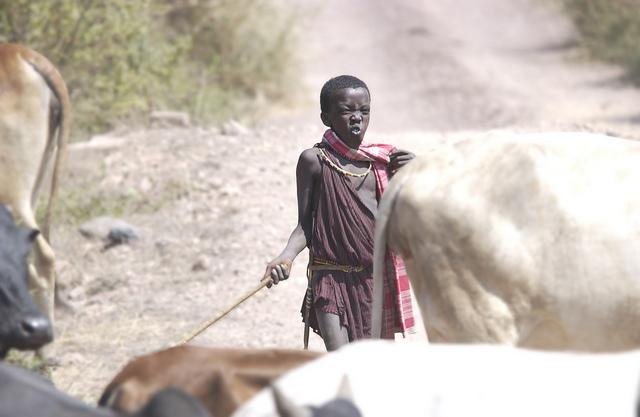What is this kid responsible for?

Choices:
A) selling cows
B) punishing cows
C) herding cows
D) scaring cows herding cows 